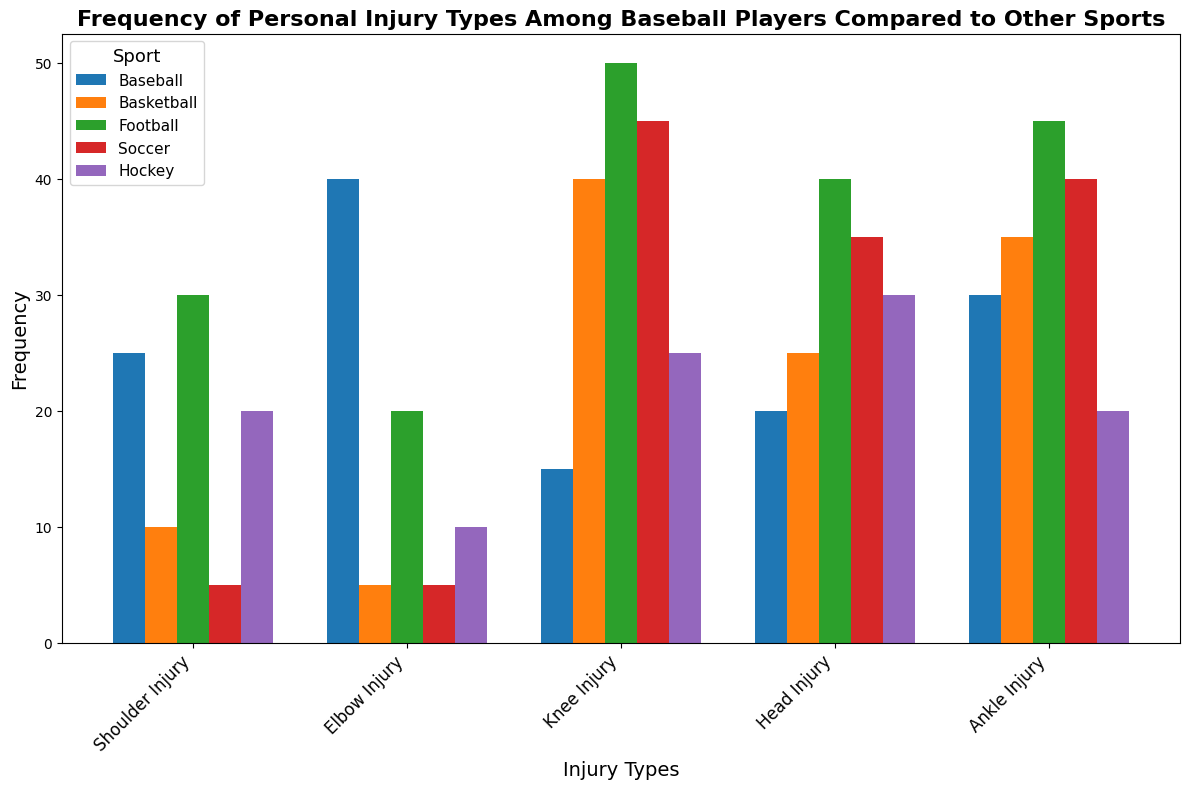Which sport has the highest frequency of head injuries? By looking at the heights of the bars corresponding to head injuries, the bar for football is the tallest.
Answer: Football How does the frequency of knee injuries in baseball compare to that in basketball? By comparing the heights of the bars for knee injuries in both sports, the basketball bar is notably higher than the baseball bar.
Answer: Basketball has more knee injuries What is the total frequency of ankle injuries across all sports? Sum the frequencies of ankle injuries for each sport: 30 (Baseball) + 35 (Basketball) + 45 (Football) + 40 (Soccer) + 20 (Hockey) = 170.
Answer: 170 Which injury type has the lowest frequency in soccer? Compare the heights of the bars for all injury types in soccer; shoulder injuries and elbow injuries have the lowest and equal height.
Answer: Shoulder Injury and Elbow Injury Which sport has the least frequency of elbow injuries, and how does it compare to the sport with the highest frequency of elbow injuries? By comparing the elbow injury bars of each sport, soccer has the lowest frequency at 5, while baseball has the highest at 40.
Answer: Soccer has the least, Baseball has the most What is the difference in frequency of shoulder injuries between baseball and hockey? Subtract the frequency of shoulder injuries in hockey from that in baseball: 25 (Baseball) - 20 (Hockey) = 5.
Answer: 5 Which injury type in football has the highest frequency, and how does it compare to the frequency of the highest injury type in baseball? Knee injuries have the highest frequency in football (50). In baseball, elbow injuries are highest (40). Therefore, knee injuries in football are 10 more than elbow injuries in baseball (50 - 40).
Answer: Football knee injuries are 10 more Compare the total frequency of injuries in baseball and basketball. Sum up the frequencies of all injury types for both sports: Baseball = 25 + 40 + 15 + 20 + 30 = 130, Basketball = 10 + 5 + 40 + 25 + 35 = 115.
Answer: Baseball has a higher total frequency What is the ratio of head injuries to knee injuries in hockey? Divide the frequency of head injuries by that of knee injuries in hockey: 30 (Head) / 25 (Knee).
Answer: 1.2 Among the sports analyzed, which has the highest frequency of injuries for a single type, and what is that type? By reviewing all injury frequencies, football knee injuries have the highest single frequency at 50.
Answer: Football knee injuries 